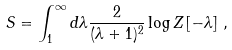<formula> <loc_0><loc_0><loc_500><loc_500>S = \int _ { 1 } ^ { \infty } d \lambda \frac { 2 } { ( \lambda + 1 ) ^ { 2 } } \log Z \left [ - \lambda \right ] \, ,</formula> 